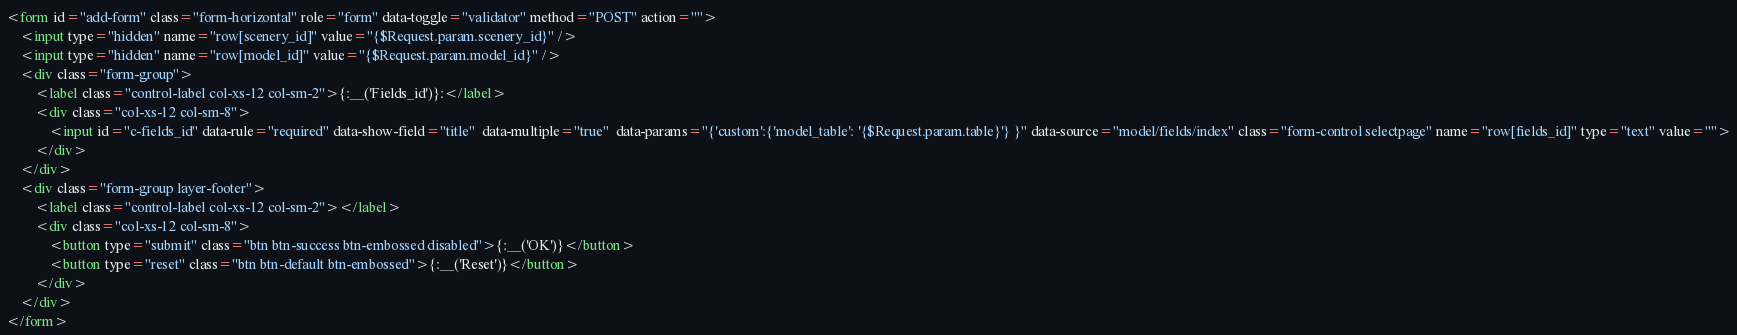<code> <loc_0><loc_0><loc_500><loc_500><_HTML_><form id="add-form" class="form-horizontal" role="form" data-toggle="validator" method="POST" action="">
    <input type="hidden" name="row[scenery_id]" value="{$Request.param.scenery_id}" />
    <input type="hidden" name="row[model_id]" value="{$Request.param.model_id}" />
    <div class="form-group">
        <label class="control-label col-xs-12 col-sm-2">{:__('Fields_id')}:</label>
        <div class="col-xs-12 col-sm-8">
            <input id="c-fields_id" data-rule="required" data-show-field="title"  data-multiple="true"  data-params="{'custom':{'model_table': '{$Request.param.table}'} }" data-source="model/fields/index" class="form-control selectpage" name="row[fields_id]" type="text" value="">
        </div>
    </div>
    <div class="form-group layer-footer">
        <label class="control-label col-xs-12 col-sm-2"></label>
        <div class="col-xs-12 col-sm-8">
            <button type="submit" class="btn btn-success btn-embossed disabled">{:__('OK')}</button>
            <button type="reset" class="btn btn-default btn-embossed">{:__('Reset')}</button>
        </div>
    </div>
</form>
</code> 